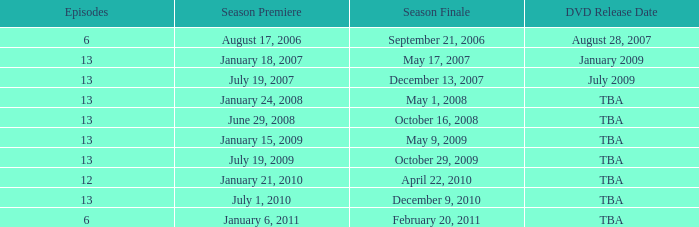Which season had fewer than 13 episodes and aired its season finale on February 20, 2011? 1.0. 